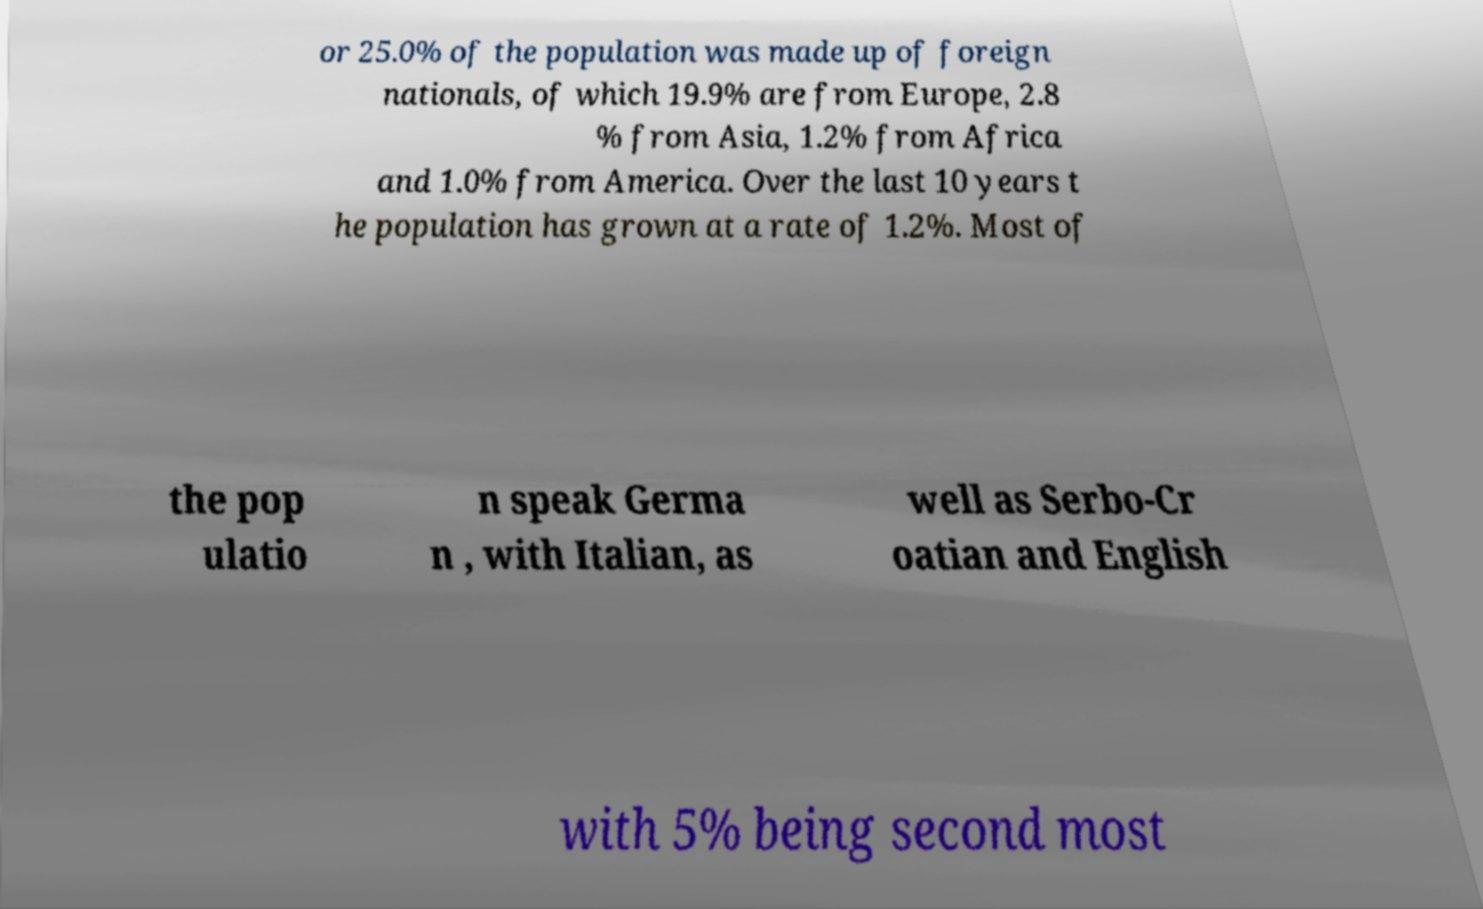Please identify and transcribe the text found in this image. or 25.0% of the population was made up of foreign nationals, of which 19.9% are from Europe, 2.8 % from Asia, 1.2% from Africa and 1.0% from America. Over the last 10 years t he population has grown at a rate of 1.2%. Most of the pop ulatio n speak Germa n , with Italian, as well as Serbo-Cr oatian and English with 5% being second most 